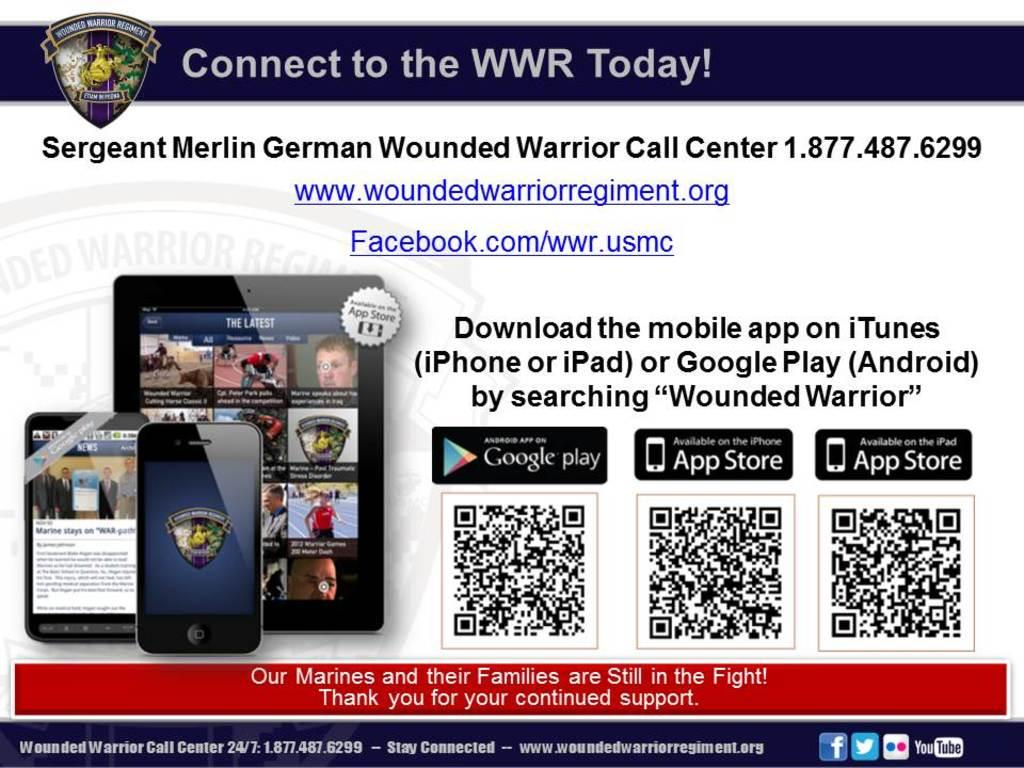<image>
Give a short and clear explanation of the subsequent image. an ad reading Connect to the WWR Today and shows you can download and app 